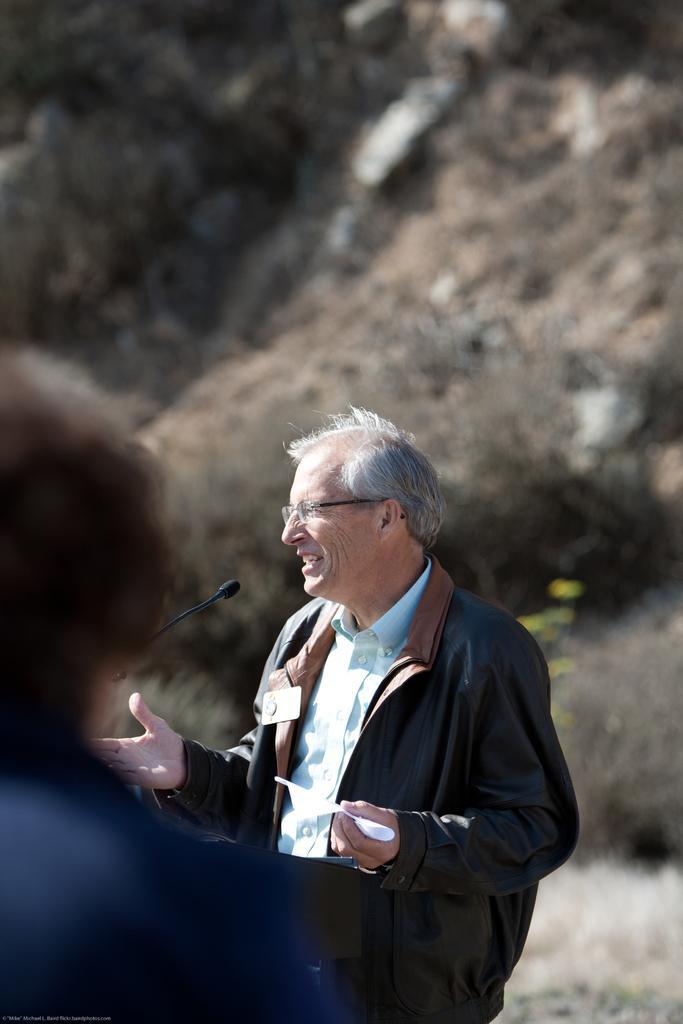In one or two sentences, can you explain what this image depicts? In this image I can see two people with different color dresses. I can see the mic in-front of one person. In the background I can see the trees and it is blurred. 